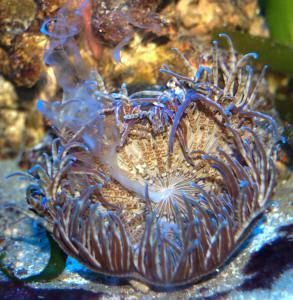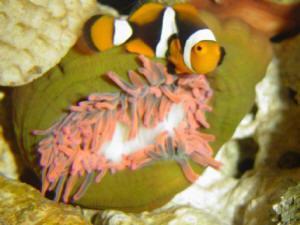The first image is the image on the left, the second image is the image on the right. Evaluate the accuracy of this statement regarding the images: "There are no fish in the left image.". Is it true? Answer yes or no. Yes. The first image is the image on the left, the second image is the image on the right. Examine the images to the left and right. Is the description "The left image shows clown fish swimming in the noodle-like yellowish tendrils of anemone." accurate? Answer yes or no. No. 